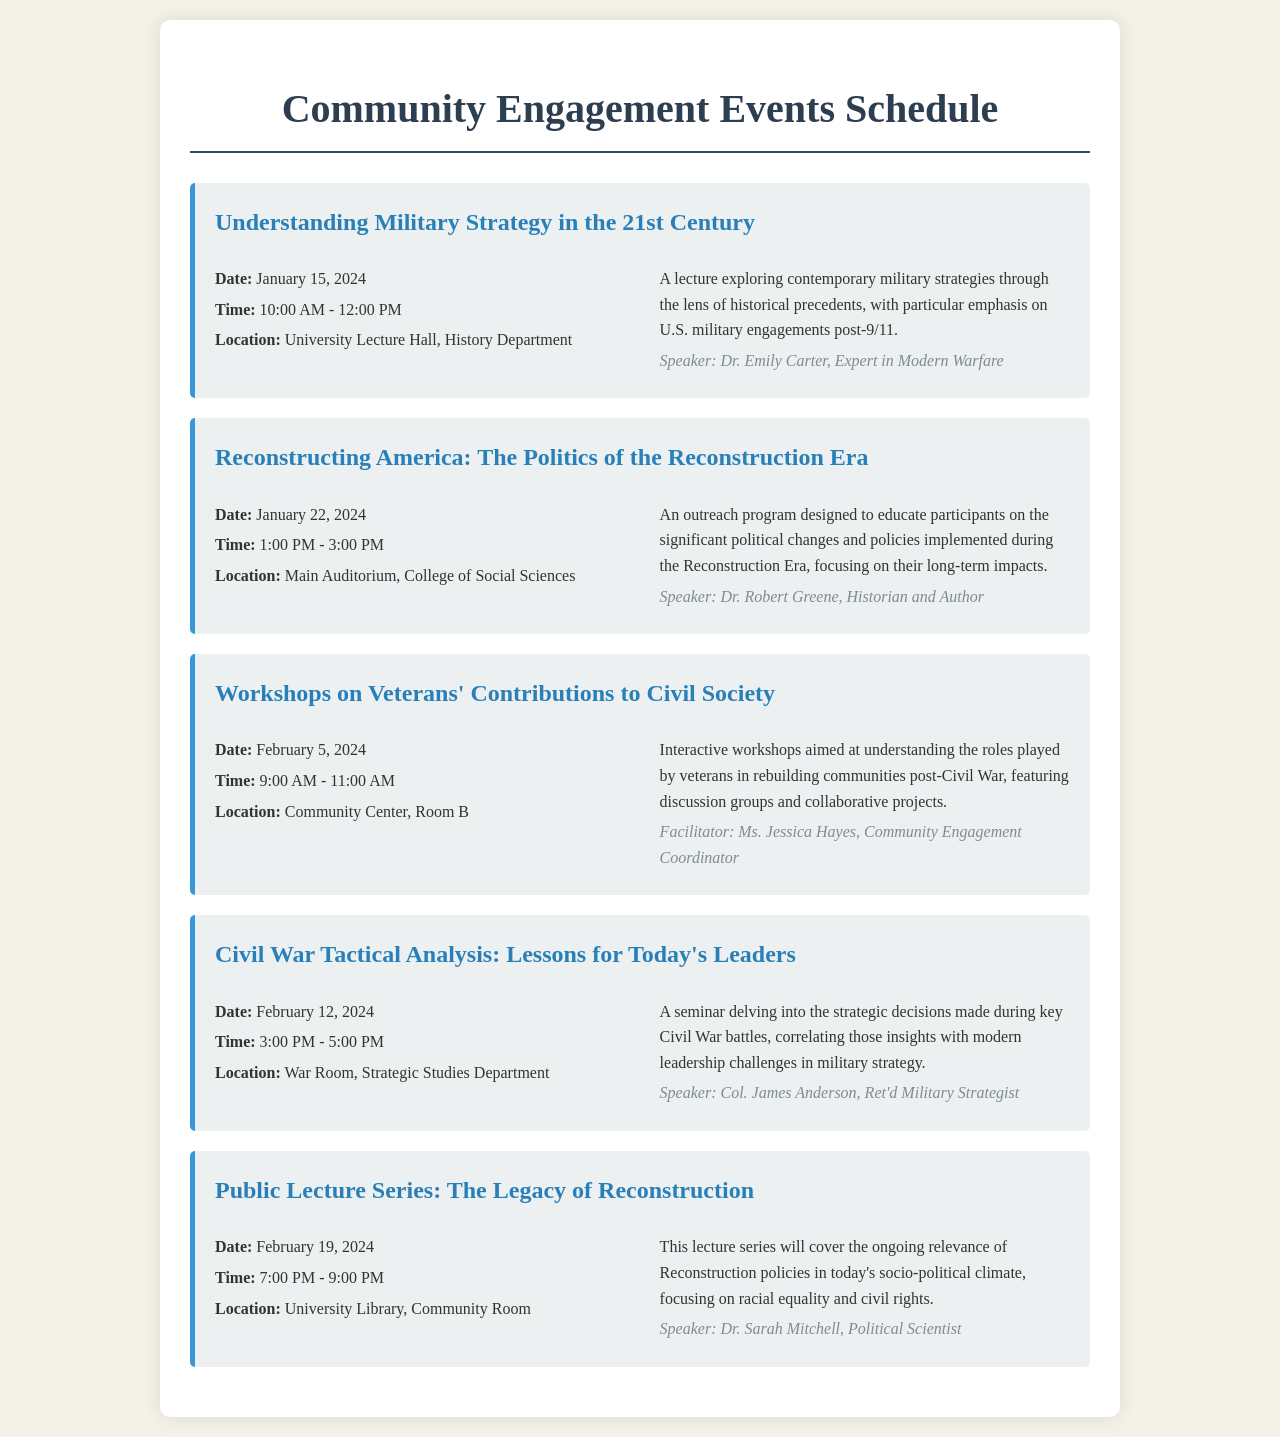What is the date of the first event? The first event, "Understanding Military Strategy in the 21st Century," is scheduled for January 15, 2024.
Answer: January 15, 2024 Who is the speaker for the Civil War Tactical Analysis seminar? The speaker for the "Civil War Tactical Analysis: Lessons for Today's Leaders" seminar is Col. James Anderson, Ret'd Military Strategist.
Answer: Col. James Anderson What time does the workshop on Veterans' Contributions to Civil Society start? The workshop on Veterans' Contributions to Civil Society begins at 9:00 AM.
Answer: 9:00 AM How many outreach programs are listed in the schedule? There are two outreach programs listed: "Reconstructing America: The Politics of the Reconstruction Era" and "Workshops on Veterans' Contributions to Civil Society."
Answer: 2 What is the main focus of the Public Lecture Series? The main focus of the Public Lecture Series is on the ongoing relevance of Reconstruction policies in today's socio-political climate, particularly racial equality and civil rights.
Answer: Racial equality and civil rights What location hosts the second event? The second event, "Reconstructing America: The Politics of the Reconstruction Era," will be held in the Main Auditorium, College of Social Sciences.
Answer: Main Auditorium, College of Social Sciences 